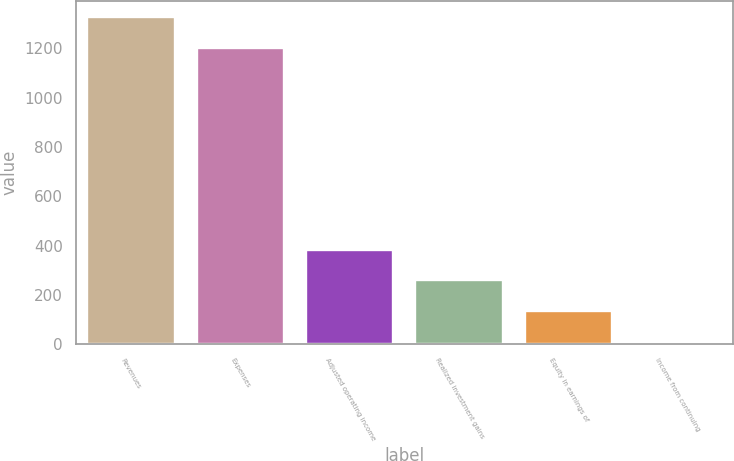<chart> <loc_0><loc_0><loc_500><loc_500><bar_chart><fcel>Revenues<fcel>Expenses<fcel>Adjusted operating income<fcel>Realized investment gains<fcel>Equity in earnings of<fcel>Income from continuing<nl><fcel>1326.8<fcel>1202<fcel>383.4<fcel>258.6<fcel>133.8<fcel>9<nl></chart> 